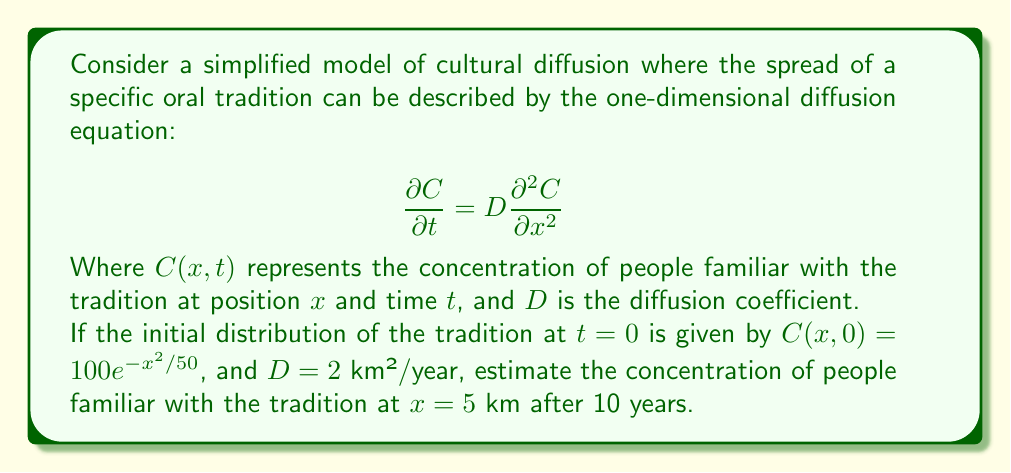Give your solution to this math problem. To solve this problem, we need to use the solution to the one-dimensional diffusion equation with an initial Gaussian distribution. The solution is given by:

$$C(x,t) = \frac{M}{\sqrt{4\pi Dt + \sigma^2}} \exp\left(-\frac{x^2}{4Dt + \sigma^2}\right)$$

Where:
- $M$ is the total amount of the diffusing quantity
- $\sigma^2$ is the initial variance of the Gaussian distribution
- $D$ is the diffusion coefficient
- $t$ is the time
- $x$ is the position

From the initial condition, we can identify:
- $\sigma^2 = 50$ km²
- $M = 100\sqrt{50\pi}$ (found by integrating the initial distribution)

Now, let's follow the steps:

1) Substitute the known values into the equation:
   $$C(x,t) = \frac{100\sqrt{50\pi}}{\sqrt{4\pi \cdot 2 \cdot 10 + 50}} \exp\left(-\frac{x^2}{4 \cdot 2 \cdot 10 + 50}\right)$$

2) Simplify:
   $$C(x,t) = \frac{100\sqrt{50\pi}}{\sqrt{80\pi + 50}} \exp\left(-\frac{x^2}{130}\right)$$

3) For $x = 5$ km:
   $$C(5,10) = \frac{100\sqrt{50\pi}}{\sqrt{80\pi + 50}} \exp\left(-\frac{25}{130}\right)$$

4) Calculate the result:
   $$C(5,10) \approx 44.72$$

Therefore, the concentration of people familiar with the tradition at $x = 5$ km after 10 years is approximately 44.72 people per unit area.
Answer: 44.72 people per unit area 